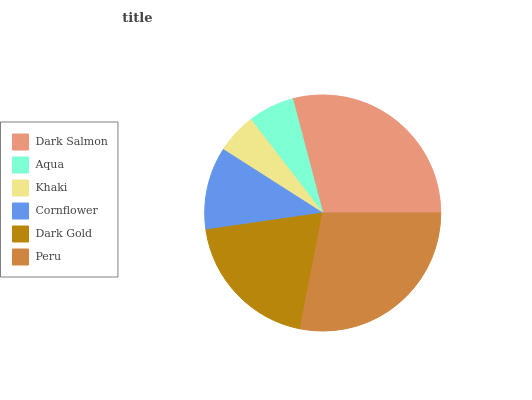Is Khaki the minimum?
Answer yes or no. Yes. Is Dark Salmon the maximum?
Answer yes or no. Yes. Is Aqua the minimum?
Answer yes or no. No. Is Aqua the maximum?
Answer yes or no. No. Is Dark Salmon greater than Aqua?
Answer yes or no. Yes. Is Aqua less than Dark Salmon?
Answer yes or no. Yes. Is Aqua greater than Dark Salmon?
Answer yes or no. No. Is Dark Salmon less than Aqua?
Answer yes or no. No. Is Dark Gold the high median?
Answer yes or no. Yes. Is Cornflower the low median?
Answer yes or no. Yes. Is Cornflower the high median?
Answer yes or no. No. Is Aqua the low median?
Answer yes or no. No. 